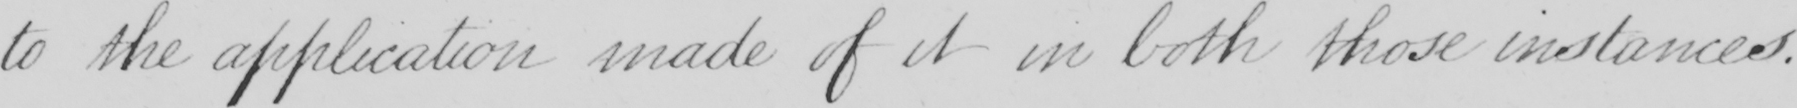Can you tell me what this handwritten text says? to the application made of it in both those instances . 